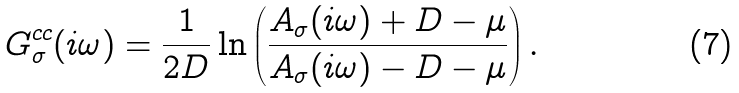Convert formula to latex. <formula><loc_0><loc_0><loc_500><loc_500>G _ { \sigma } ^ { c c } ( i \omega ) = \frac { 1 } { 2 D } \ln \left ( \frac { A _ { \sigma } ( i \omega ) + D - \mu } { A _ { \sigma } ( i \omega ) - D - \mu } \right ) .</formula> 